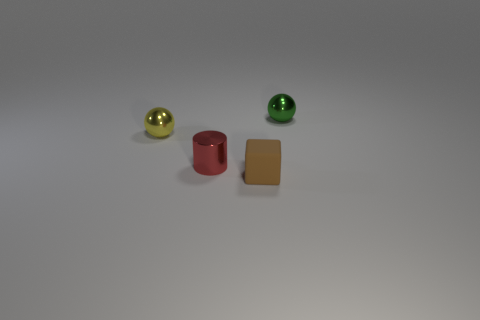Add 2 brown matte cubes. How many objects exist? 6 Subtract all cylinders. How many objects are left? 3 Subtract all cyan cylinders. Subtract all brown cubes. How many cylinders are left? 1 Subtract all blue cylinders. Subtract all green metallic balls. How many objects are left? 3 Add 1 red cylinders. How many red cylinders are left? 2 Add 3 tiny green rubber cubes. How many tiny green rubber cubes exist? 3 Subtract 1 yellow spheres. How many objects are left? 3 